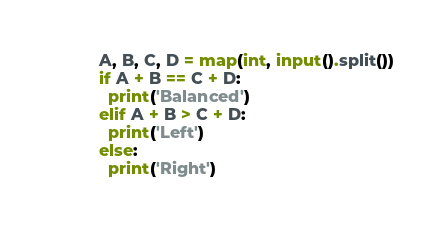<code> <loc_0><loc_0><loc_500><loc_500><_Python_>A, B, C, D = map(int, input().split())
if A + B == C + D:
  print('Balanced')
elif A + B > C + D:
  print('Left')
else:
  print('Right')</code> 